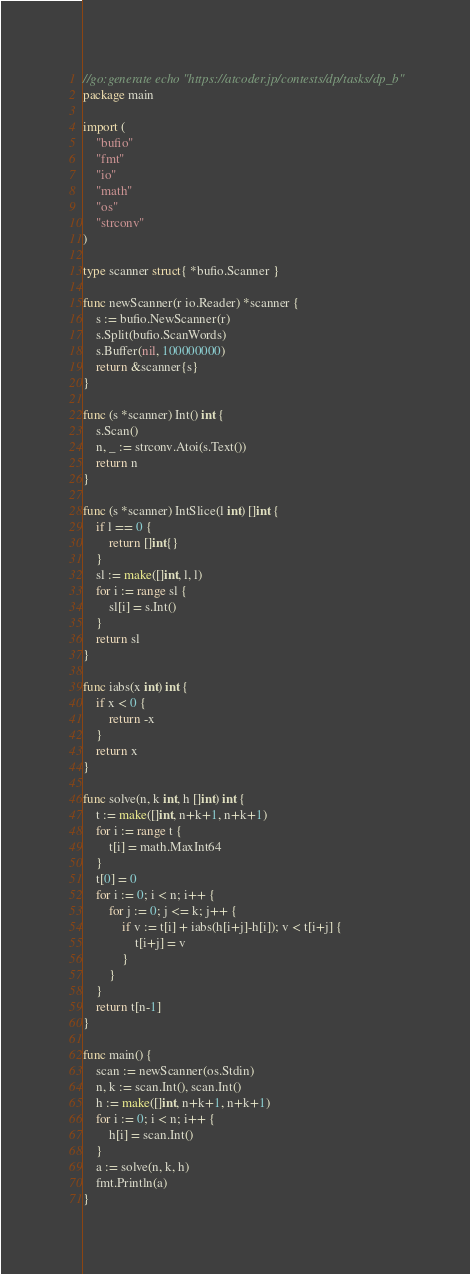Convert code to text. <code><loc_0><loc_0><loc_500><loc_500><_Go_>//go:generate echo "https://atcoder.jp/contests/dp/tasks/dp_b"
package main

import (
	"bufio"
	"fmt"
	"io"
	"math"
	"os"
	"strconv"
)

type scanner struct{ *bufio.Scanner }

func newScanner(r io.Reader) *scanner {
	s := bufio.NewScanner(r)
	s.Split(bufio.ScanWords)
	s.Buffer(nil, 100000000)
	return &scanner{s}
}

func (s *scanner) Int() int {
	s.Scan()
	n, _ := strconv.Atoi(s.Text())
	return n
}

func (s *scanner) IntSlice(l int) []int {
	if l == 0 {
		return []int{}
	}
	sl := make([]int, l, l)
	for i := range sl {
		sl[i] = s.Int()
	}
	return sl
}

func iabs(x int) int {
	if x < 0 {
		return -x
	}
	return x
}

func solve(n, k int, h []int) int {
	t := make([]int, n+k+1, n+k+1)
	for i := range t {
		t[i] = math.MaxInt64
	}
	t[0] = 0
	for i := 0; i < n; i++ {
		for j := 0; j <= k; j++ {
			if v := t[i] + iabs(h[i+j]-h[i]); v < t[i+j] {
				t[i+j] = v
			}
		}
	}
	return t[n-1]
}

func main() {
	scan := newScanner(os.Stdin)
	n, k := scan.Int(), scan.Int()
	h := make([]int, n+k+1, n+k+1)
	for i := 0; i < n; i++ {
		h[i] = scan.Int()
	}
	a := solve(n, k, h)
	fmt.Println(a)
}
</code> 